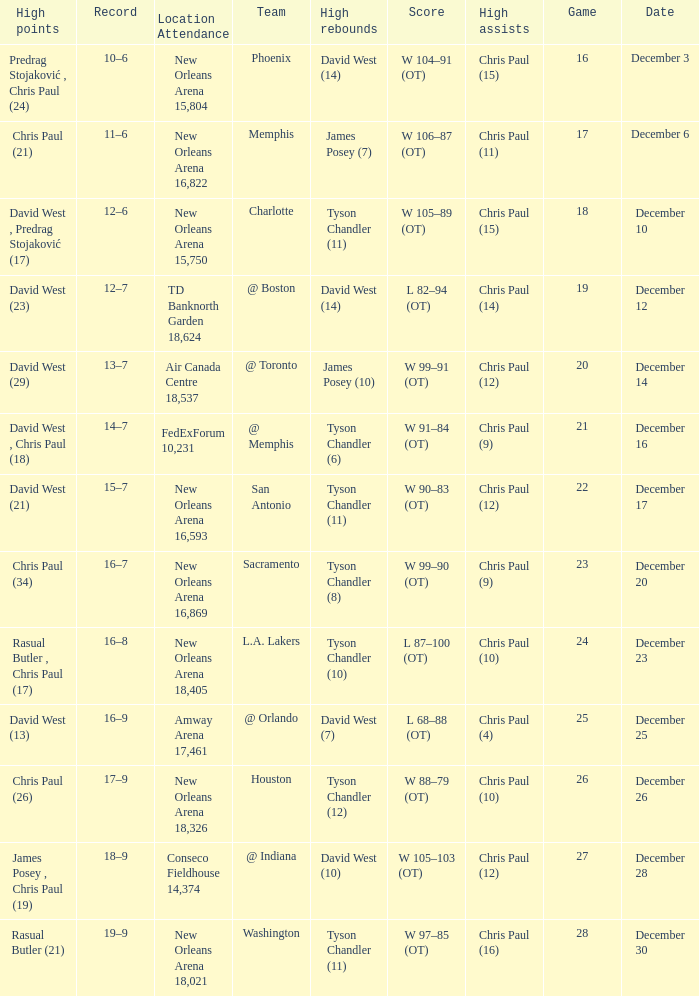What is Score, when Team is "@ Memphis"? W 91–84 (OT). 